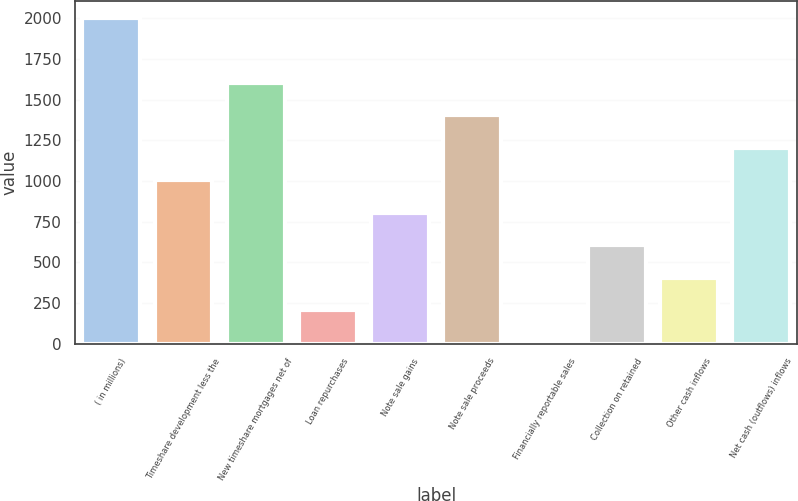<chart> <loc_0><loc_0><loc_500><loc_500><bar_chart><fcel>( in millions)<fcel>Timeshare development less the<fcel>New timeshare mortgages net of<fcel>Loan repurchases<fcel>Note sale gains<fcel>Note sale proceeds<fcel>Financially reportable sales<fcel>Collection on retained<fcel>Other cash inflows<fcel>Net cash (outflows) inflows<nl><fcel>2003<fcel>1003.5<fcel>1603.2<fcel>203.9<fcel>803.6<fcel>1403.3<fcel>4<fcel>603.7<fcel>403.8<fcel>1203.4<nl></chart> 